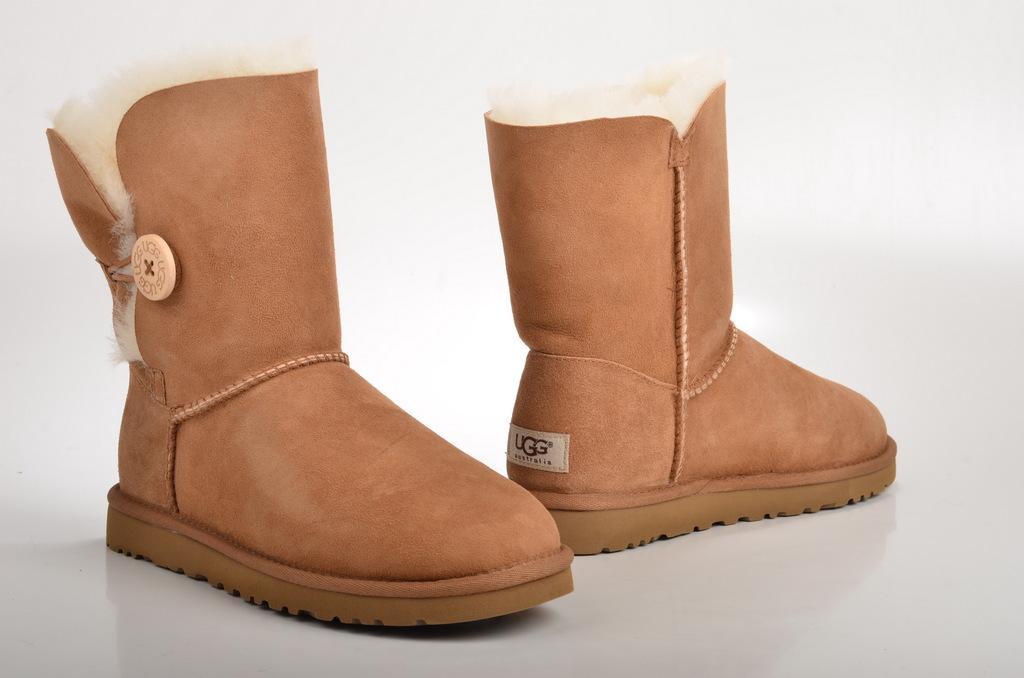How would you summarize this image in a sentence or two? In this image, we can see shoes on the white surface. 